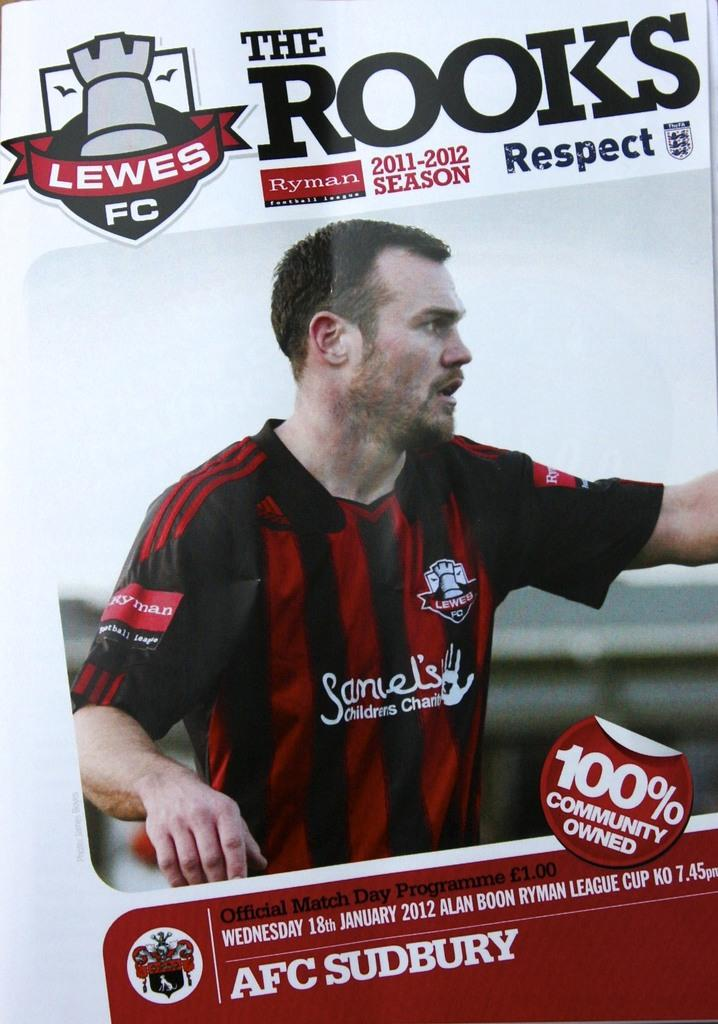<image>
Summarize the visual content of the image. An "Official Match Day Programme" for "Lewes FC The Rooks" shows an image of one of the players. 